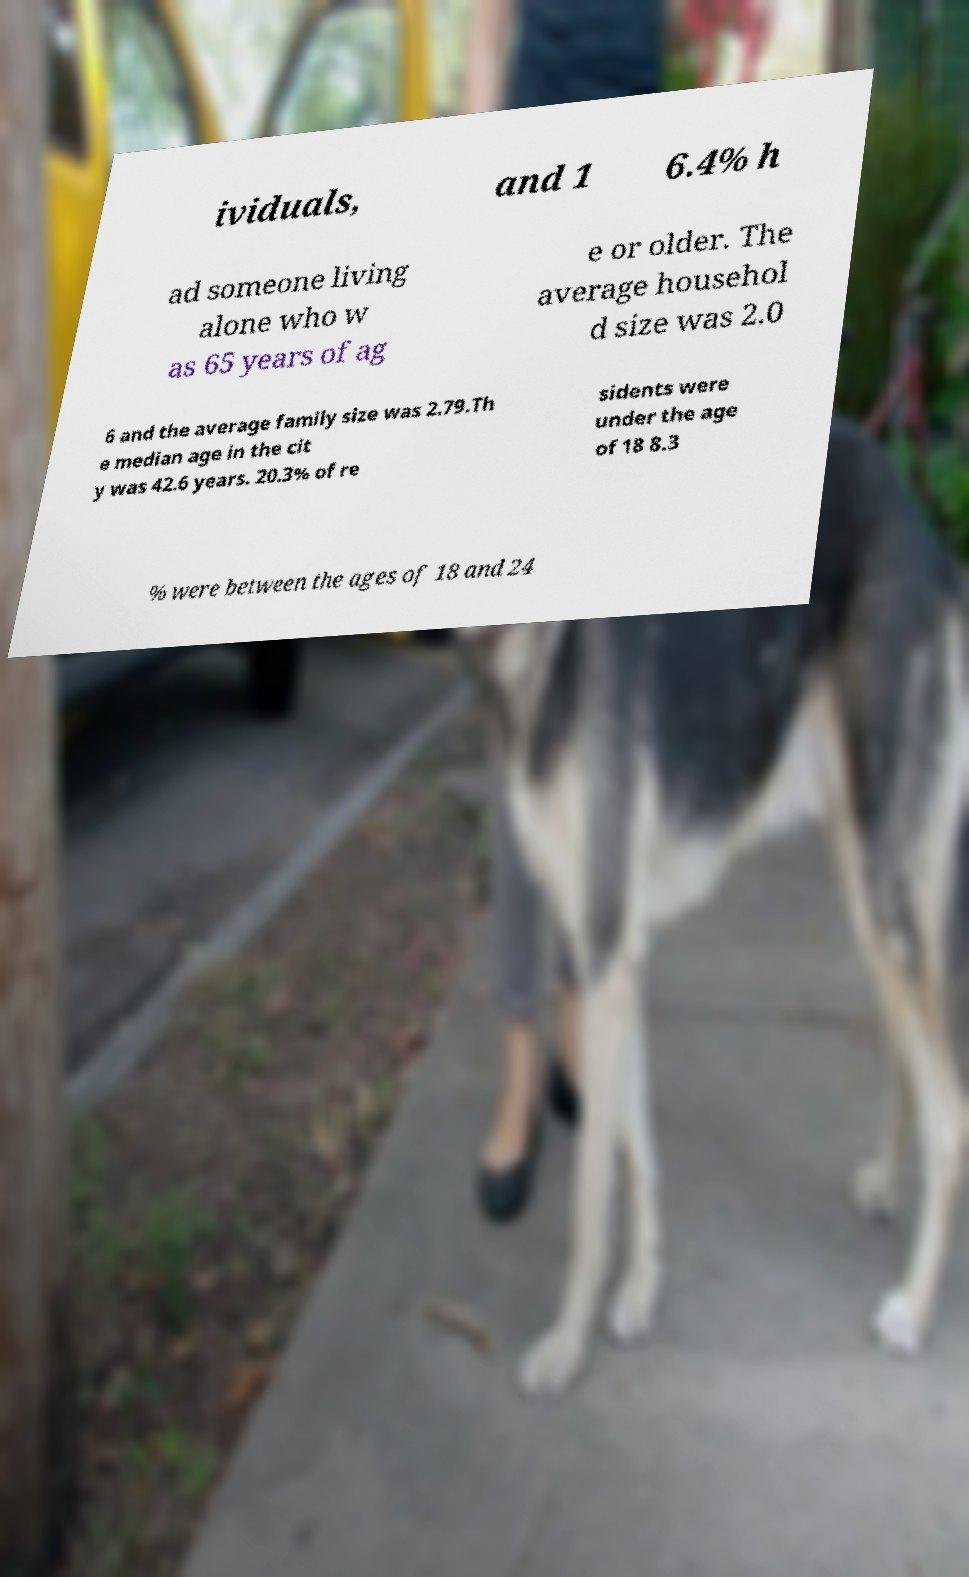Can you accurately transcribe the text from the provided image for me? ividuals, and 1 6.4% h ad someone living alone who w as 65 years of ag e or older. The average househol d size was 2.0 6 and the average family size was 2.79.Th e median age in the cit y was 42.6 years. 20.3% of re sidents were under the age of 18 8.3 % were between the ages of 18 and 24 